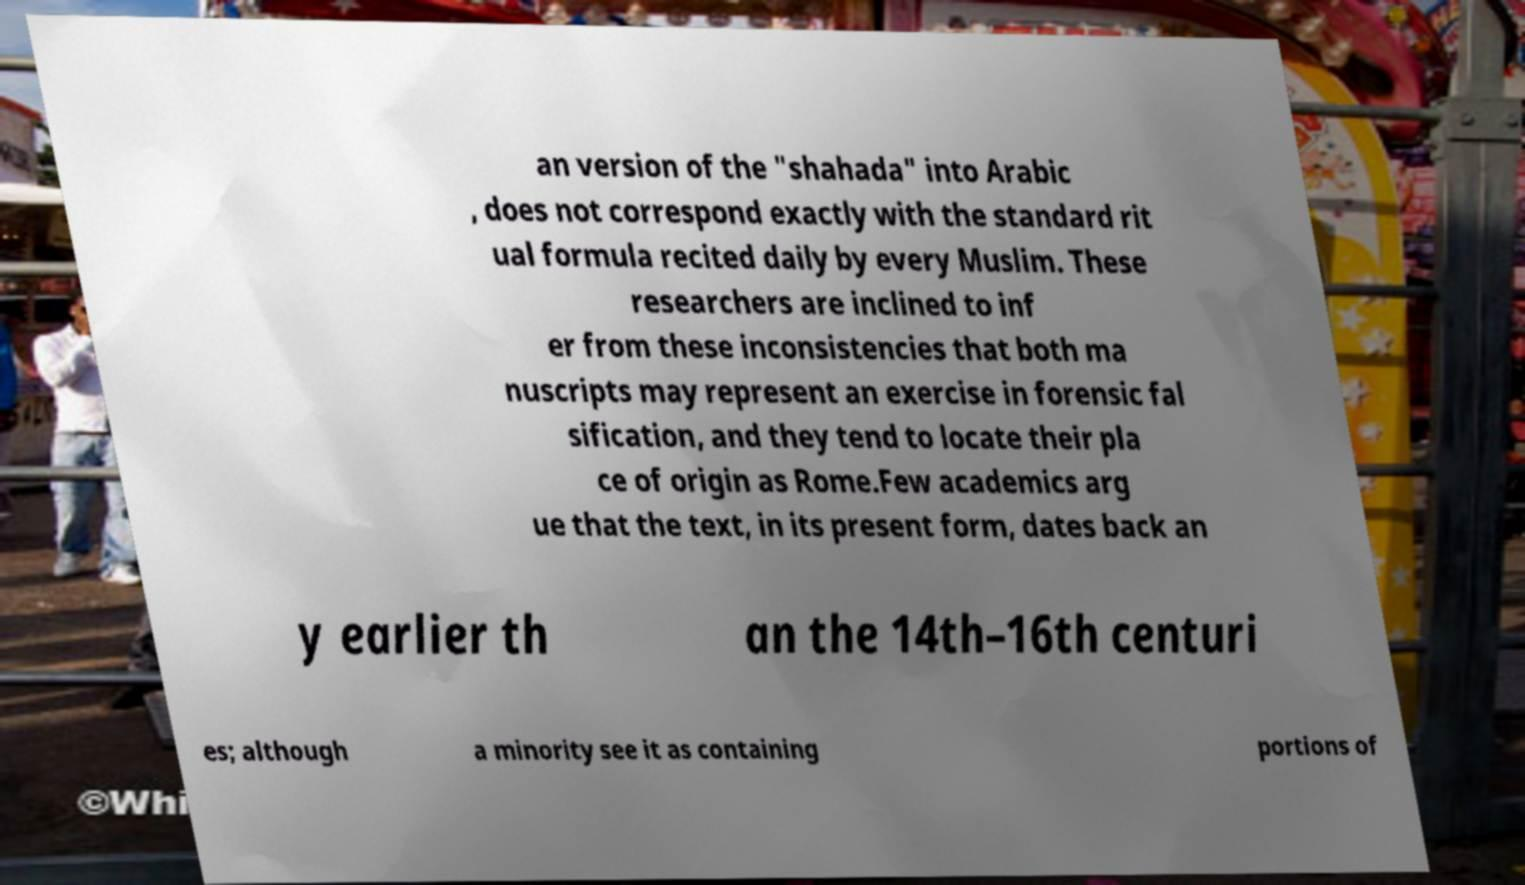There's text embedded in this image that I need extracted. Can you transcribe it verbatim? an version of the "shahada" into Arabic , does not correspond exactly with the standard rit ual formula recited daily by every Muslim. These researchers are inclined to inf er from these inconsistencies that both ma nuscripts may represent an exercise in forensic fal sification, and they tend to locate their pla ce of origin as Rome.Few academics arg ue that the text, in its present form, dates back an y earlier th an the 14th–16th centuri es; although a minority see it as containing portions of 